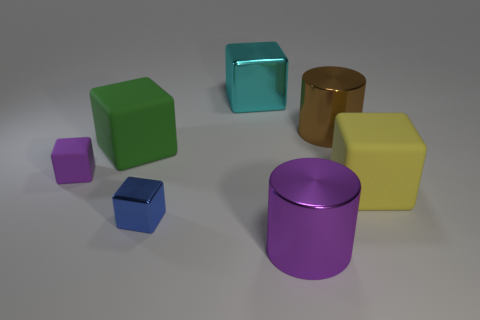Are there any big things on the right side of the small shiny object?
Ensure brevity in your answer.  Yes. There is a small blue thing; does it have the same shape as the thing that is left of the big green cube?
Offer a very short reply. Yes. What is the color of the big cube that is made of the same material as the purple cylinder?
Your answer should be compact. Cyan. The tiny metal thing has what color?
Ensure brevity in your answer.  Blue. Is the big brown object made of the same material as the big cyan object that is to the right of the tiny blue thing?
Make the answer very short. Yes. How many things are on the left side of the big purple metallic cylinder and behind the large yellow block?
Your answer should be compact. 3. There is a yellow matte object that is the same size as the green block; what shape is it?
Your response must be concise. Cube. There is a metal cube that is behind the cylinder behind the tiny purple thing; are there any blocks that are on the left side of it?
Give a very brief answer. Yes. Is the color of the small matte thing the same as the big cylinder that is in front of the small purple matte block?
Your answer should be compact. Yes. What number of big metal cylinders have the same color as the tiny rubber object?
Keep it short and to the point. 1. 